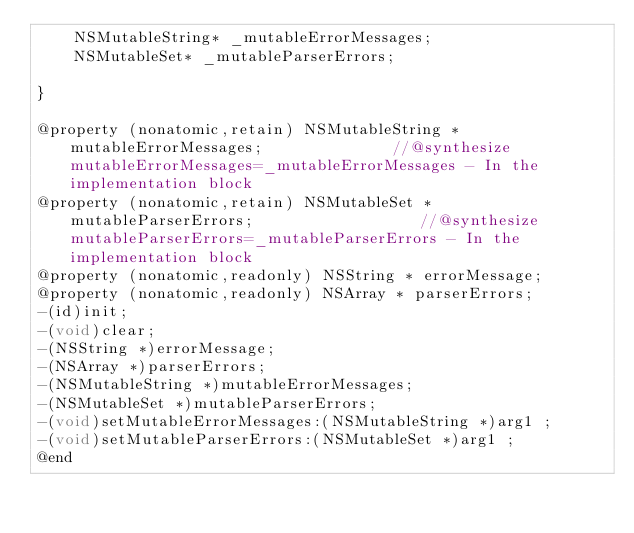<code> <loc_0><loc_0><loc_500><loc_500><_C_>	NSMutableString* _mutableErrorMessages;
	NSMutableSet* _mutableParserErrors;

}

@property (nonatomic,retain) NSMutableString * mutableErrorMessages;              //@synthesize mutableErrorMessages=_mutableErrorMessages - In the implementation block
@property (nonatomic,retain) NSMutableSet * mutableParserErrors;                  //@synthesize mutableParserErrors=_mutableParserErrors - In the implementation block
@property (nonatomic,readonly) NSString * errorMessage; 
@property (nonatomic,readonly) NSArray * parserErrors; 
-(id)init;
-(void)clear;
-(NSString *)errorMessage;
-(NSArray *)parserErrors;
-(NSMutableString *)mutableErrorMessages;
-(NSMutableSet *)mutableParserErrors;
-(void)setMutableErrorMessages:(NSMutableString *)arg1 ;
-(void)setMutableParserErrors:(NSMutableSet *)arg1 ;
@end

</code> 